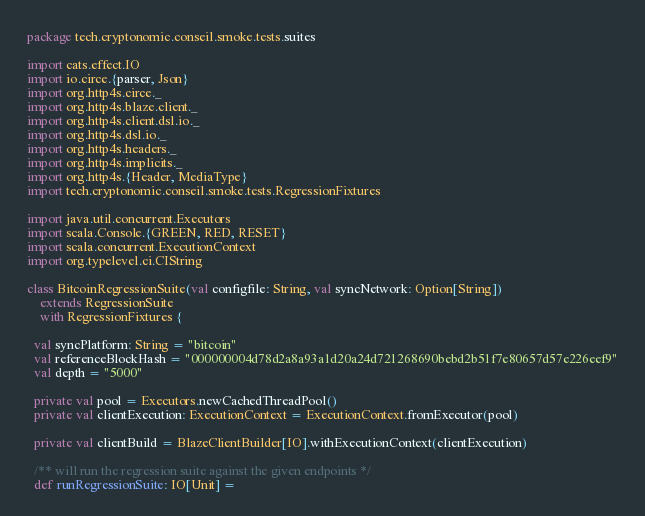Convert code to text. <code><loc_0><loc_0><loc_500><loc_500><_Scala_>package tech.cryptonomic.conseil.smoke.tests.suites

import cats.effect.IO
import io.circe.{parser, Json}
import org.http4s.circe._
import org.http4s.blaze.client._
import org.http4s.client.dsl.io._
import org.http4s.dsl.io._
import org.http4s.headers._
import org.http4s.implicits._
import org.http4s.{Header, MediaType}
import tech.cryptonomic.conseil.smoke.tests.RegressionFixtures

import java.util.concurrent.Executors
import scala.Console.{GREEN, RED, RESET}
import scala.concurrent.ExecutionContext
import org.typelevel.ci.CIString

class BitcoinRegressionSuite(val configfile: String, val syncNetwork: Option[String])
    extends RegressionSuite
    with RegressionFixtures {

  val syncPlatform: String = "bitcoin"
  val referenceBlockHash = "000000004d78d2a8a93a1d20a24d721268690bebd2b51f7e80657d57e226eef9"
  val depth = "5000"

  private val pool = Executors.newCachedThreadPool()
  private val clientExecution: ExecutionContext = ExecutionContext.fromExecutor(pool)

  private val clientBuild = BlazeClientBuilder[IO].withExecutionContext(clientExecution)

  /** will run the regression suite against the given endpoints */
  def runRegressionSuite: IO[Unit] =</code> 